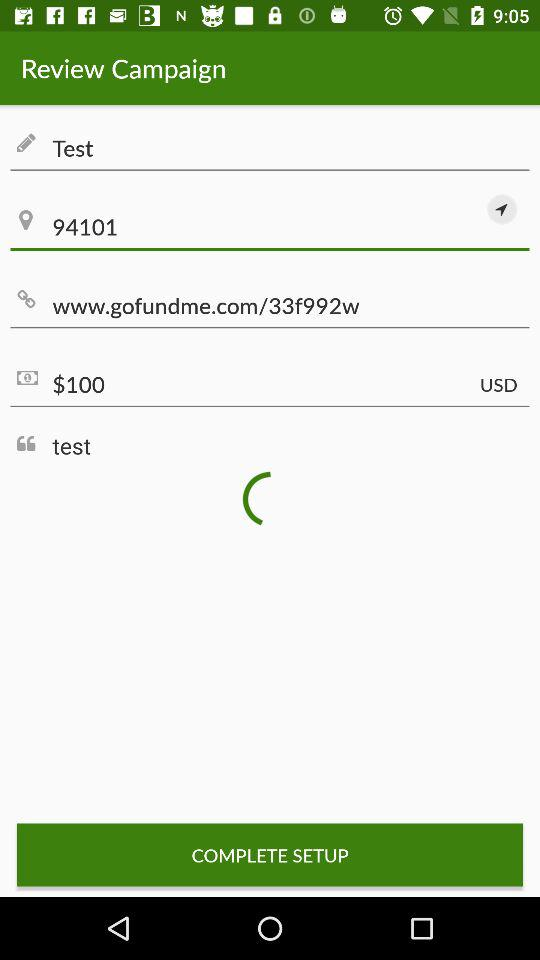What website is given? The given website is "www.gofundme.com/33f992w". 